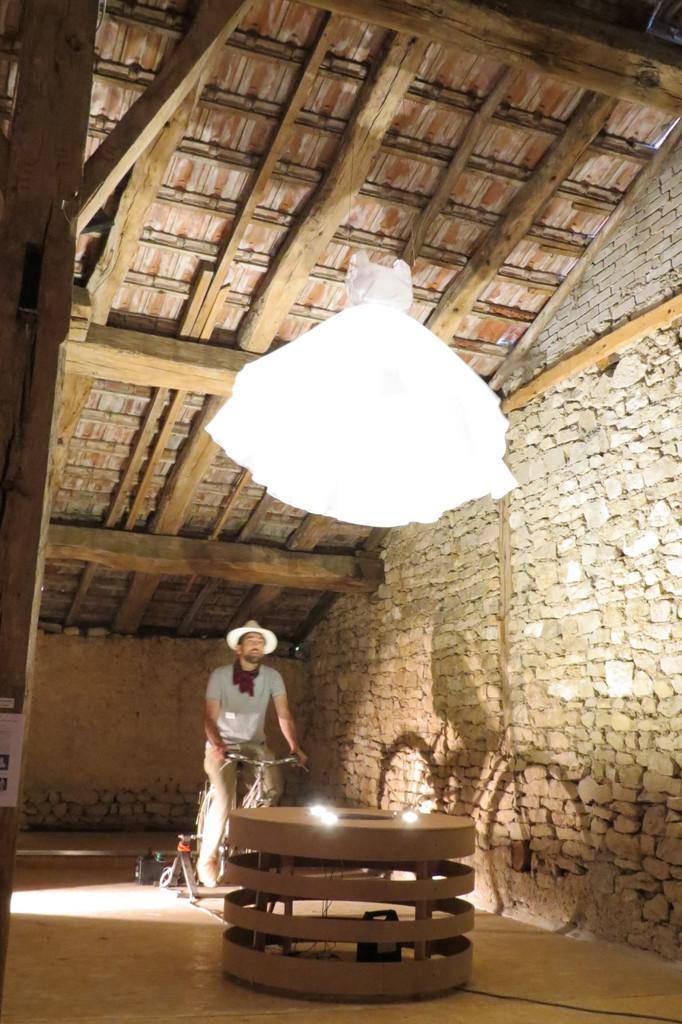Can you describe this image briefly? In this image I can see a man is sitting on a cycle. Here I can see lights on a wooden object. Here I can see a wall and white color object is hanging to a ceiling. The man is wearing a hat. 